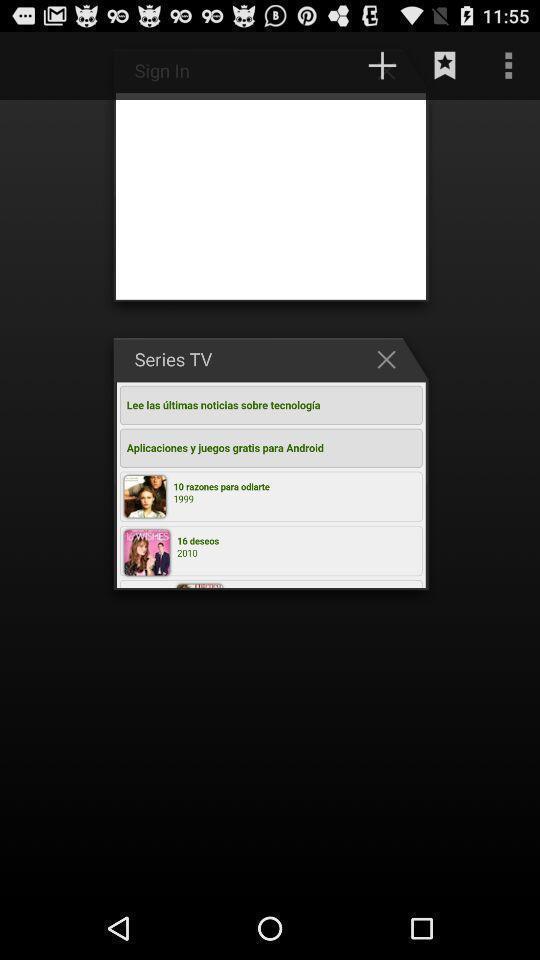Describe the key features of this screenshot. Screen displaying the list of tabs. 